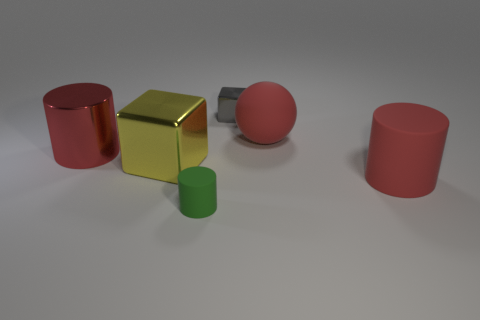Add 1 big purple matte spheres. How many objects exist? 7 Subtract all blocks. How many objects are left? 4 Add 4 red shiny cylinders. How many red shiny cylinders are left? 5 Add 1 small gray rubber balls. How many small gray rubber balls exist? 1 Subtract 1 gray blocks. How many objects are left? 5 Subtract all large matte objects. Subtract all cylinders. How many objects are left? 1 